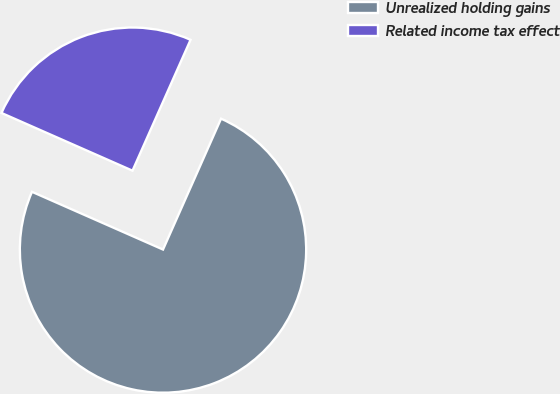<chart> <loc_0><loc_0><loc_500><loc_500><pie_chart><fcel>Unrealized holding gains<fcel>Related income tax effect<nl><fcel>74.96%<fcel>25.04%<nl></chart> 